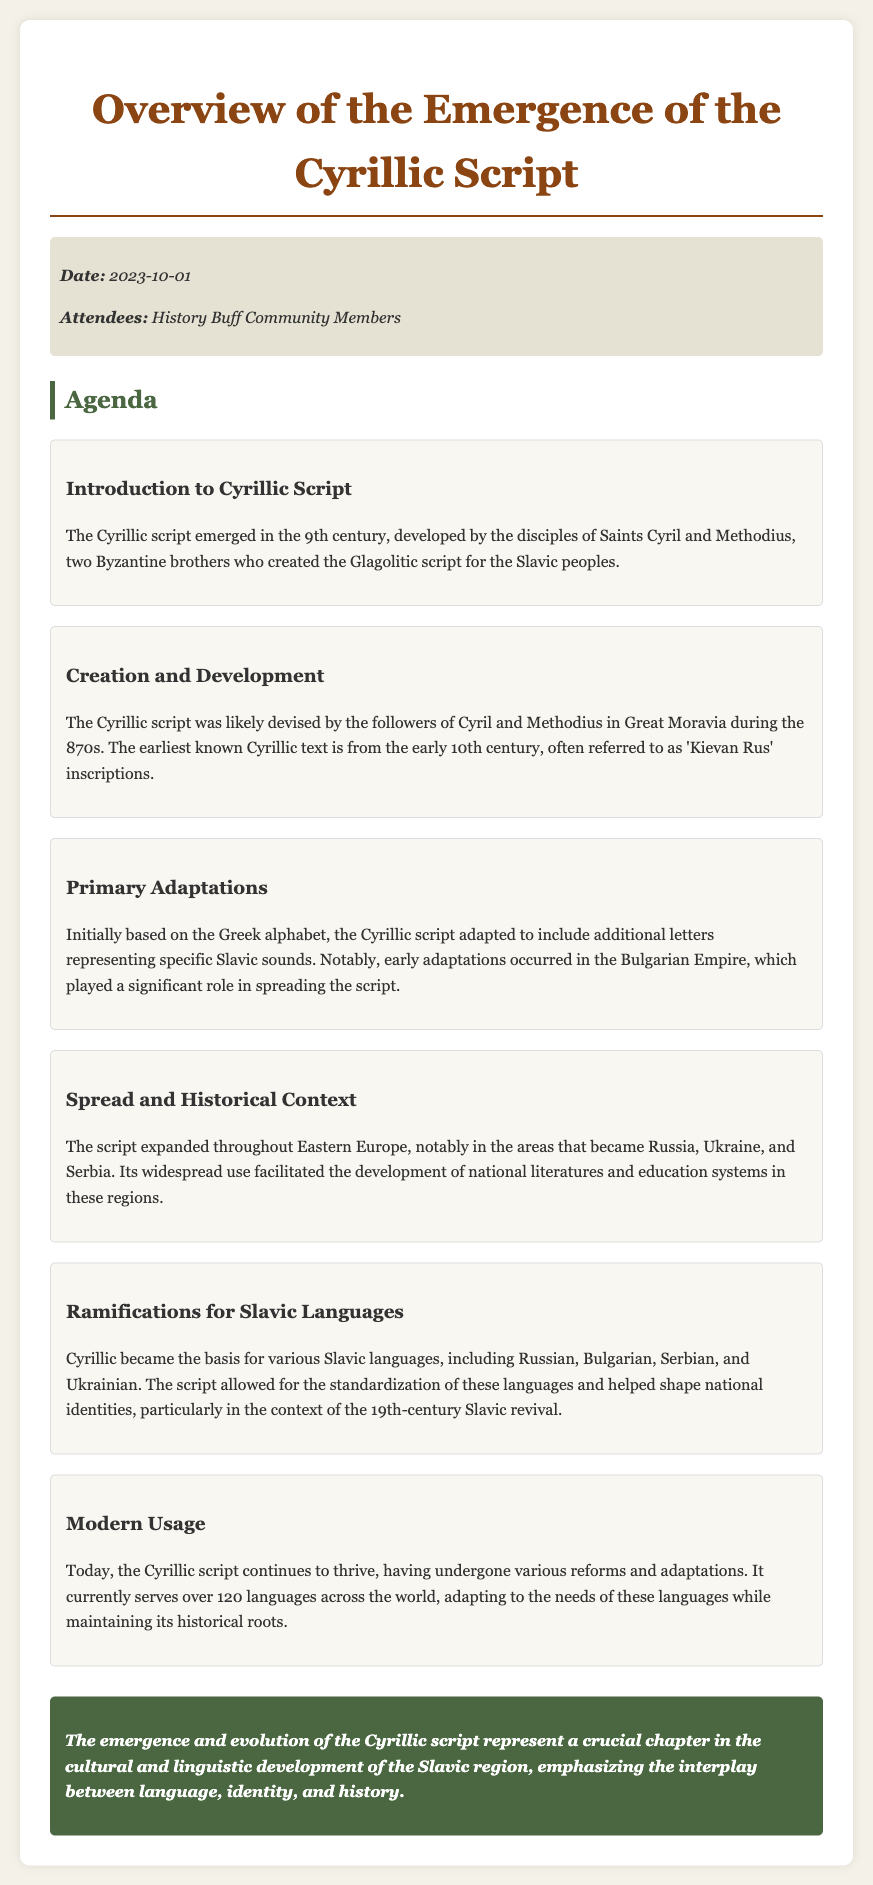What year did the Cyrillic script emerge? The document states that the Cyrillic script emerged in the 9th century.
Answer: 9th century Who developed the Cyrillic script? According to the introduction, the Cyrillic script was developed by the disciples of Saints Cyril and Methodius.
Answer: Saints Cyril and Methodius What was the earliest known text in Cyrillic? The earliest known Cyrillic text is referred to as 'Kievan Rus' inscriptions, based on the information provided.
Answer: Kievan Rus inscriptions Which empire played a significant role in spreading the Cyrillic script? The document mentions that early adaptations occurred in the Bulgarian Empire, which was pivotal in spreading the script.
Answer: Bulgarian Empire What languages are based on the Cyrillic script? It is stated that the Cyrillic script became the basis for various Slavic languages, including Russian, Bulgarian, Serbian, and Ukrainian.
Answer: Russian, Bulgarian, Serbian, Ukrainian What historical context facilitated the script's widespread use? The textual information indicates that the script expanded throughout Eastern Europe and facilitated the development of national literatures and education systems.
Answer: Eastern Europe How many languages currently use the Cyrillic script? According to the modern usage section, the Cyrillic script serves over 120 languages across the world today.
Answer: Over 120 languages What conclusion is drawn about the evolution of the Cyrillic script? The concluding remarks highlight that the emergence and evolution of the Cyrillic script represent a crucial chapter in cultural and linguistic development.
Answer: Crucial chapter in cultural and linguistic development 